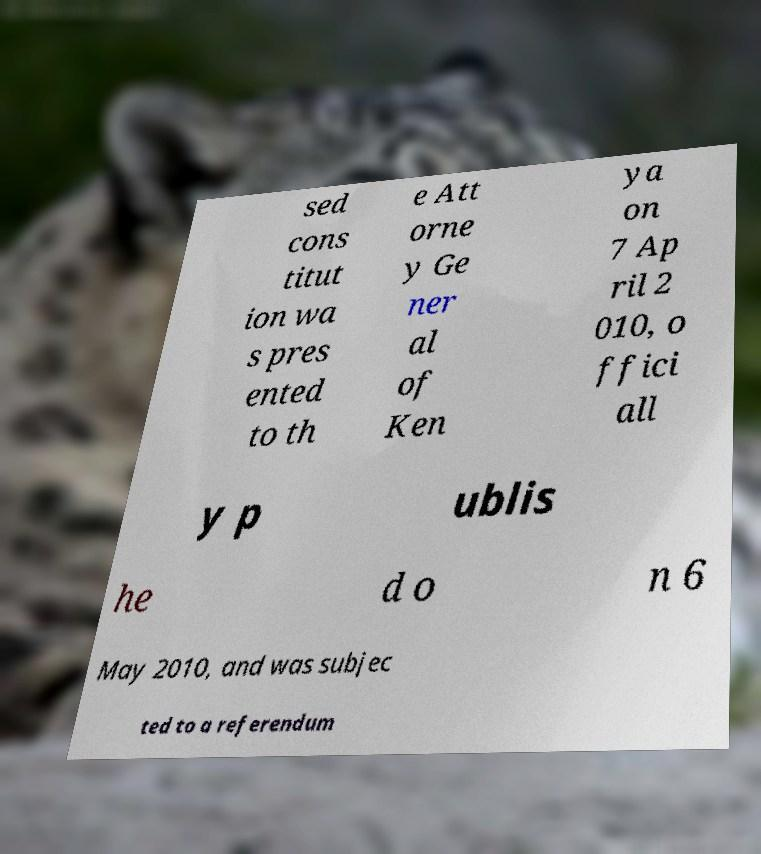Can you accurately transcribe the text from the provided image for me? sed cons titut ion wa s pres ented to th e Att orne y Ge ner al of Ken ya on 7 Ap ril 2 010, o ffici all y p ublis he d o n 6 May 2010, and was subjec ted to a referendum 